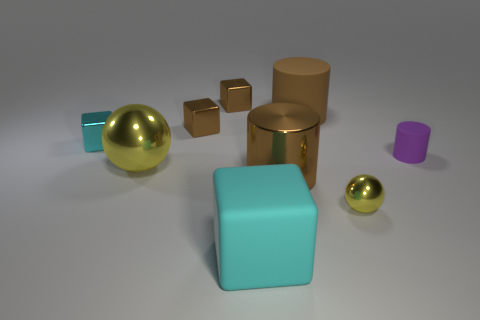Subtract all small cyan blocks. How many blocks are left? 3 Add 1 tiny shiny spheres. How many objects exist? 10 Subtract all green cubes. Subtract all cyan spheres. How many cubes are left? 4 Subtract all spheres. How many objects are left? 7 Add 7 tiny yellow things. How many tiny yellow things exist? 8 Subtract 0 yellow cylinders. How many objects are left? 9 Subtract all tiny brown objects. Subtract all brown metallic cylinders. How many objects are left? 6 Add 4 matte objects. How many matte objects are left? 7 